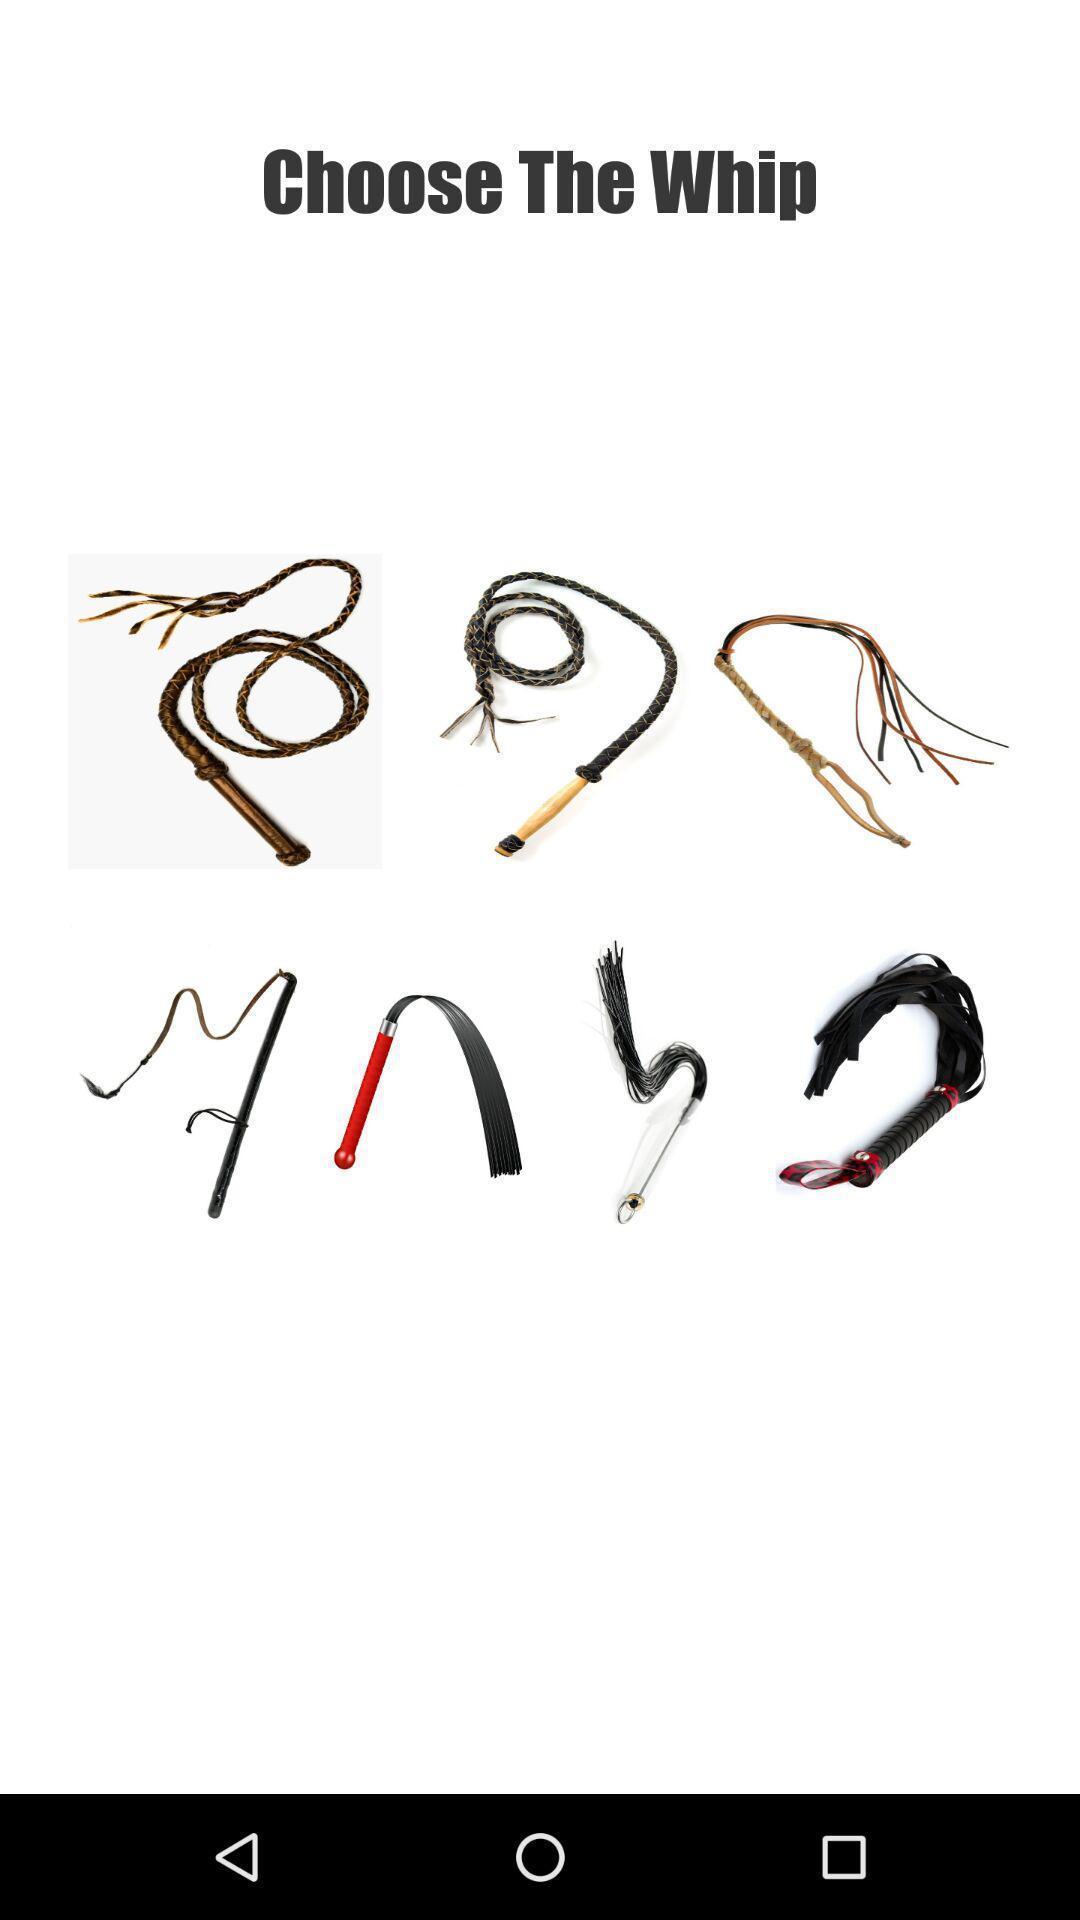Provide a textual representation of this image. Selection options for choosing product. 